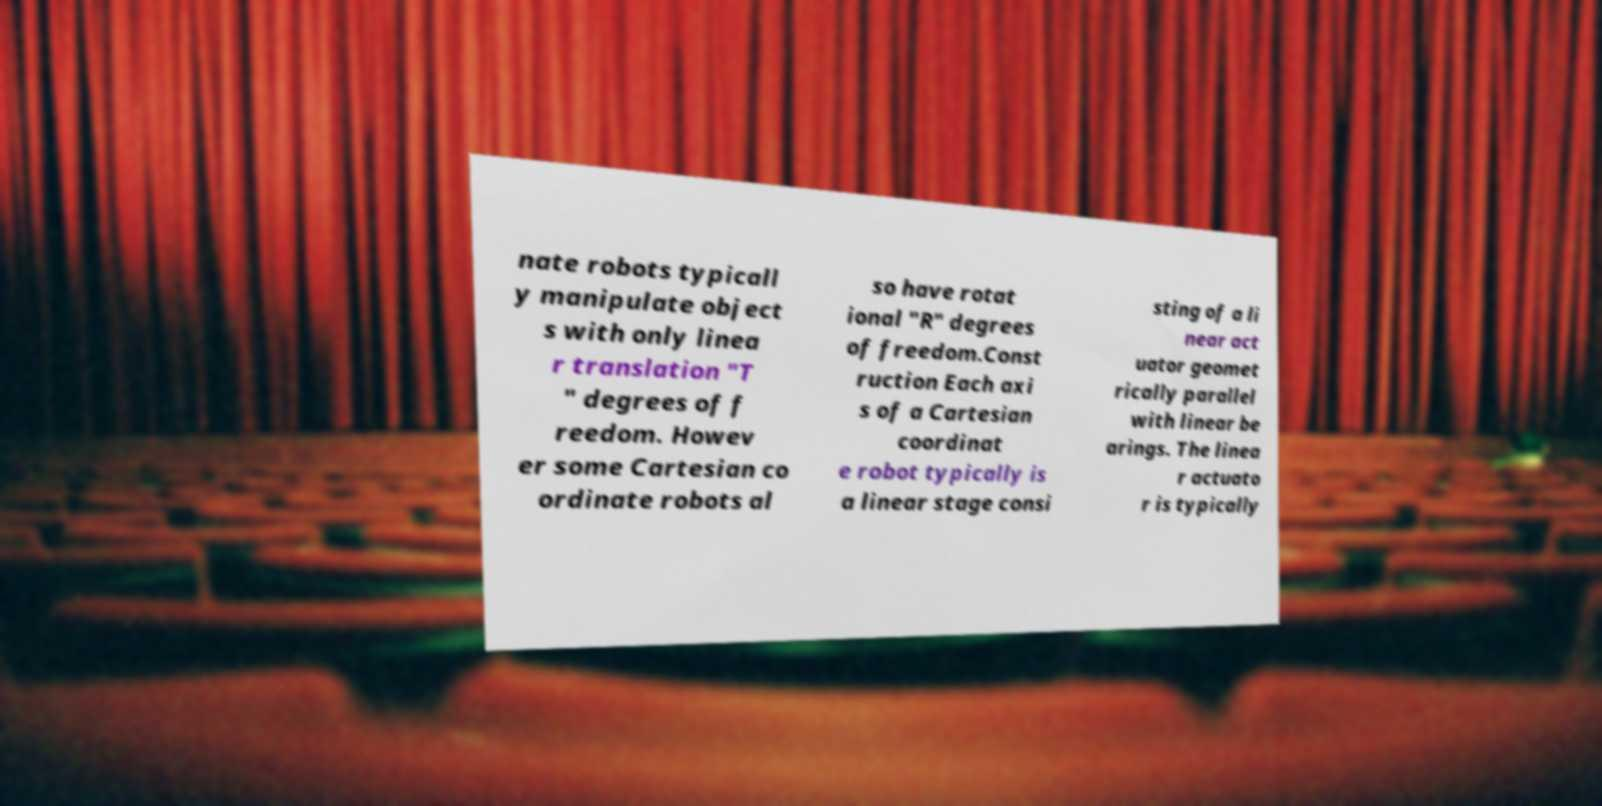Could you assist in decoding the text presented in this image and type it out clearly? nate robots typicall y manipulate object s with only linea r translation "T " degrees of f reedom. Howev er some Cartesian co ordinate robots al so have rotat ional "R" degrees of freedom.Const ruction Each axi s of a Cartesian coordinat e robot typically is a linear stage consi sting of a li near act uator geomet rically parallel with linear be arings. The linea r actuato r is typically 